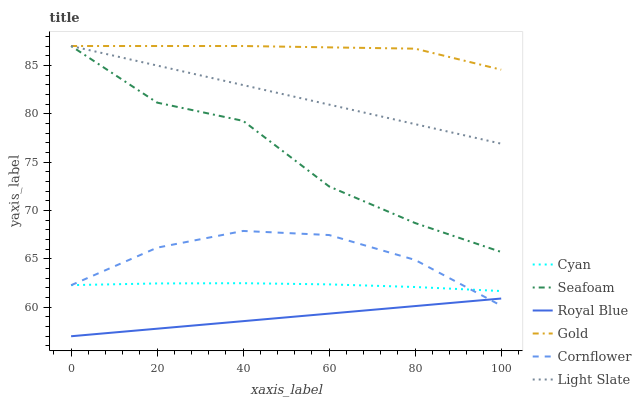Does Royal Blue have the minimum area under the curve?
Answer yes or no. Yes. Does Gold have the maximum area under the curve?
Answer yes or no. Yes. Does Light Slate have the minimum area under the curve?
Answer yes or no. No. Does Light Slate have the maximum area under the curve?
Answer yes or no. No. Is Royal Blue the smoothest?
Answer yes or no. Yes. Is Seafoam the roughest?
Answer yes or no. Yes. Is Gold the smoothest?
Answer yes or no. No. Is Gold the roughest?
Answer yes or no. No. Does Light Slate have the lowest value?
Answer yes or no. No. Does Royal Blue have the highest value?
Answer yes or no. No. Is Cyan less than Gold?
Answer yes or no. Yes. Is Gold greater than Cornflower?
Answer yes or no. Yes. Does Cyan intersect Gold?
Answer yes or no. No. 